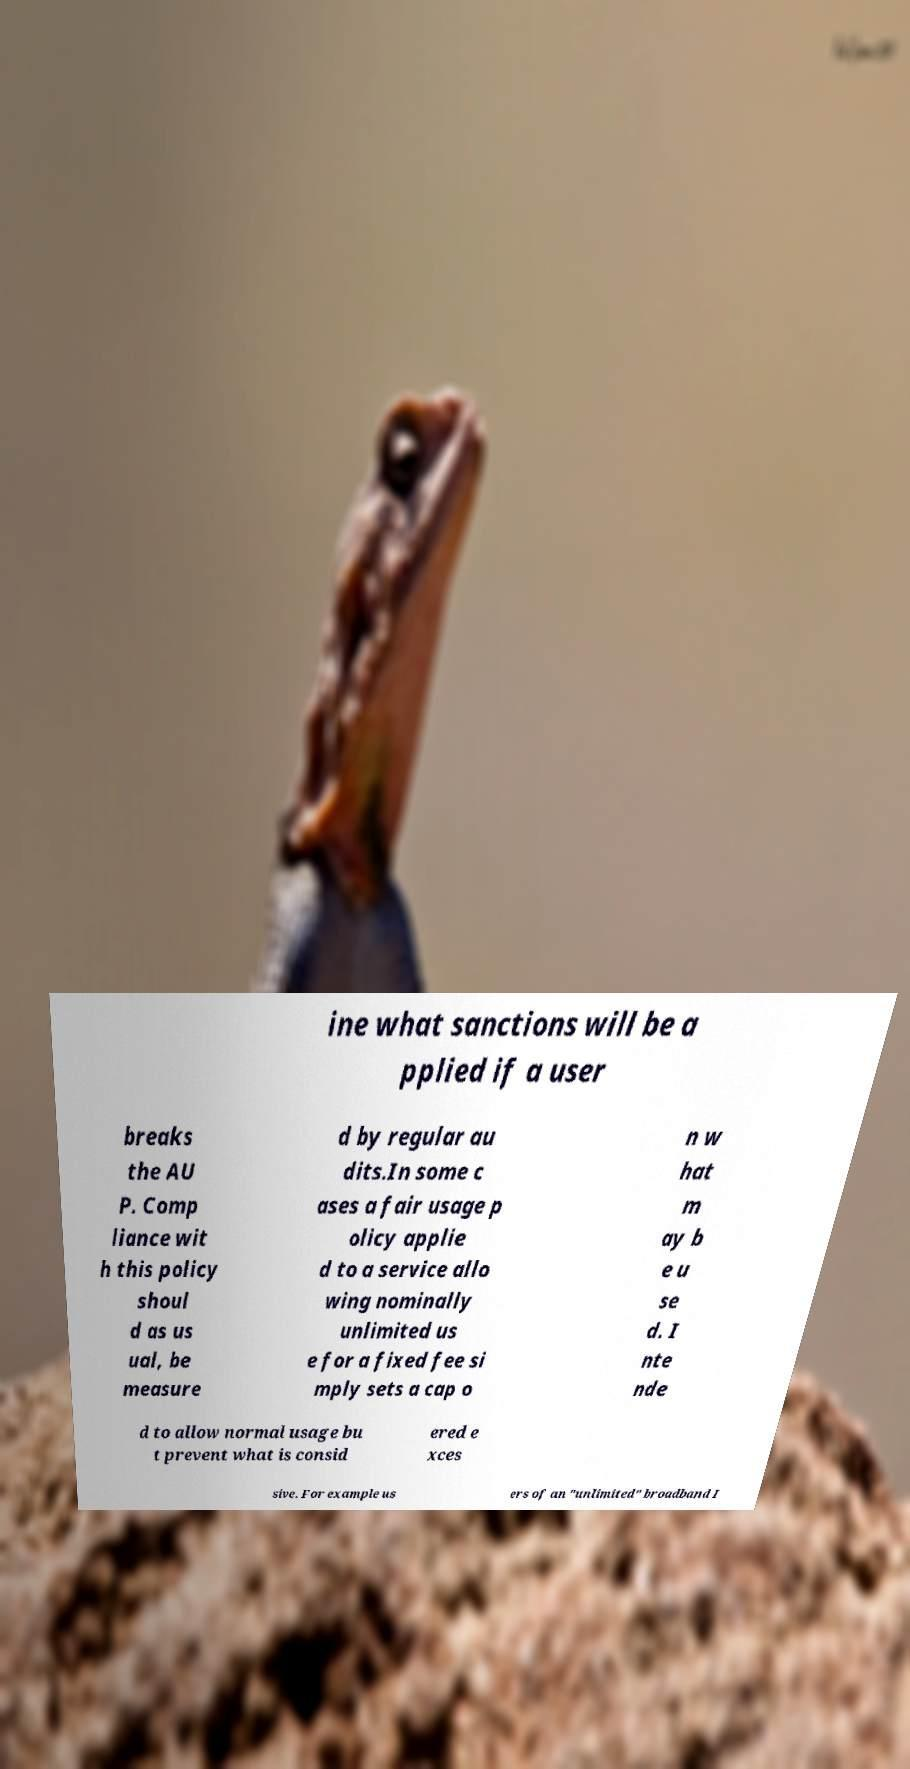Please read and relay the text visible in this image. What does it say? ine what sanctions will be a pplied if a user breaks the AU P. Comp liance wit h this policy shoul d as us ual, be measure d by regular au dits.In some c ases a fair usage p olicy applie d to a service allo wing nominally unlimited us e for a fixed fee si mply sets a cap o n w hat m ay b e u se d. I nte nde d to allow normal usage bu t prevent what is consid ered e xces sive. For example us ers of an "unlimited" broadband I 